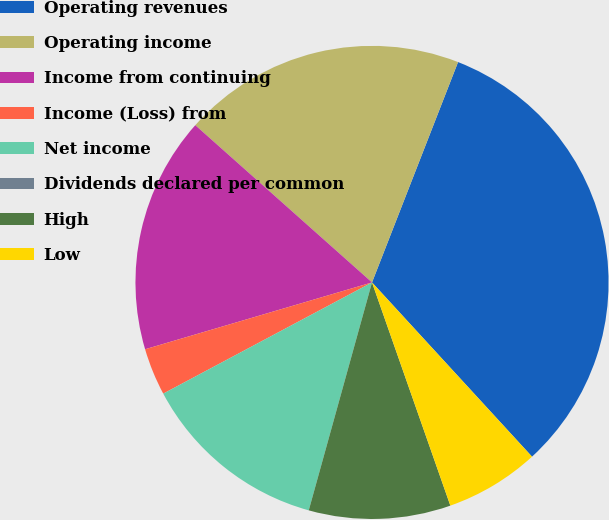Convert chart to OTSL. <chart><loc_0><loc_0><loc_500><loc_500><pie_chart><fcel>Operating revenues<fcel>Operating income<fcel>Income from continuing<fcel>Income (Loss) from<fcel>Net income<fcel>Dividends declared per common<fcel>High<fcel>Low<nl><fcel>32.25%<fcel>19.35%<fcel>16.13%<fcel>3.23%<fcel>12.9%<fcel>0.0%<fcel>9.68%<fcel>6.45%<nl></chart> 